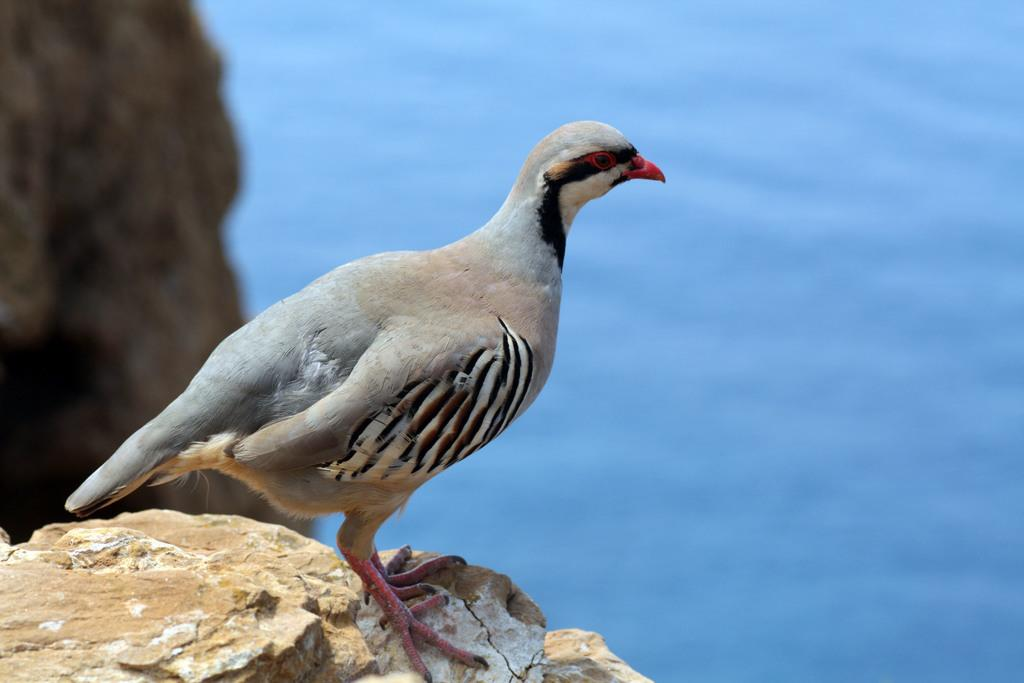What type of animal is in the image? There is a bird in the image. What is the bird standing on? The bird is standing on a rock. What color is the background of the image? The background of the image is blue. What type of copper wrench is the bird using in the image? There is no copper wrench present in the image, and the bird is not using any tools. 